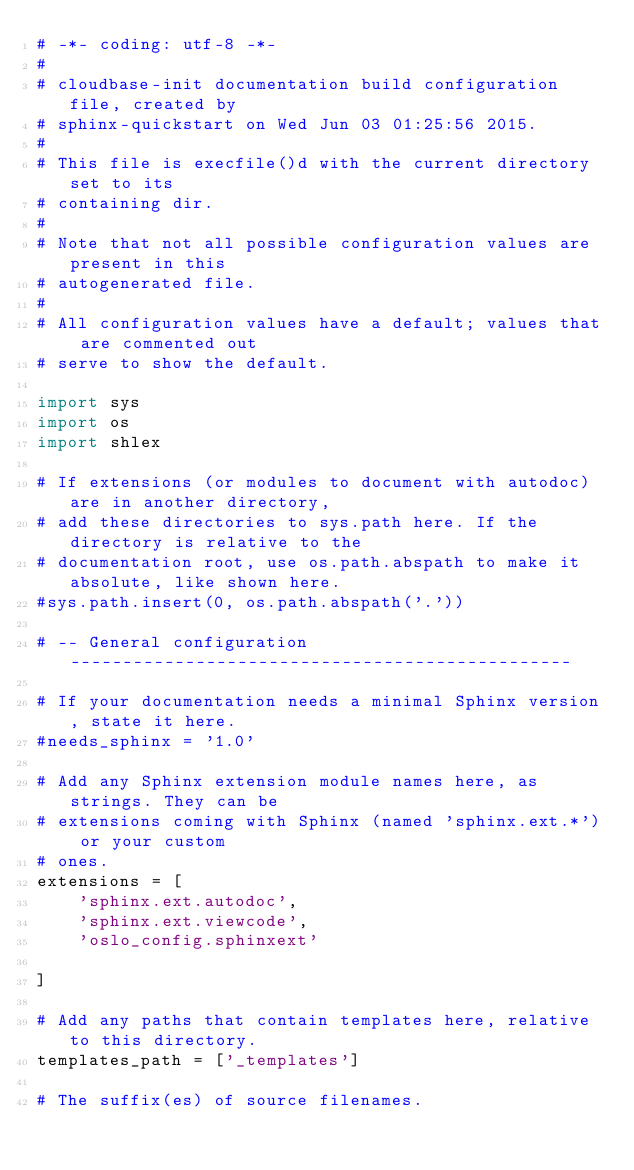Convert code to text. <code><loc_0><loc_0><loc_500><loc_500><_Python_># -*- coding: utf-8 -*-
#
# cloudbase-init documentation build configuration file, created by
# sphinx-quickstart on Wed Jun 03 01:25:56 2015.
#
# This file is execfile()d with the current directory set to its
# containing dir.
#
# Note that not all possible configuration values are present in this
# autogenerated file.
#
# All configuration values have a default; values that are commented out
# serve to show the default.

import sys
import os
import shlex

# If extensions (or modules to document with autodoc) are in another directory,
# add these directories to sys.path here. If the directory is relative to the
# documentation root, use os.path.abspath to make it absolute, like shown here.
#sys.path.insert(0, os.path.abspath('.'))

# -- General configuration ------------------------------------------------

# If your documentation needs a minimal Sphinx version, state it here.
#needs_sphinx = '1.0'

# Add any Sphinx extension module names here, as strings. They can be
# extensions coming with Sphinx (named 'sphinx.ext.*') or your custom
# ones.
extensions = [
    'sphinx.ext.autodoc',
    'sphinx.ext.viewcode',
    'oslo_config.sphinxext'

]

# Add any paths that contain templates here, relative to this directory.
templates_path = ['_templates']

# The suffix(es) of source filenames.</code> 